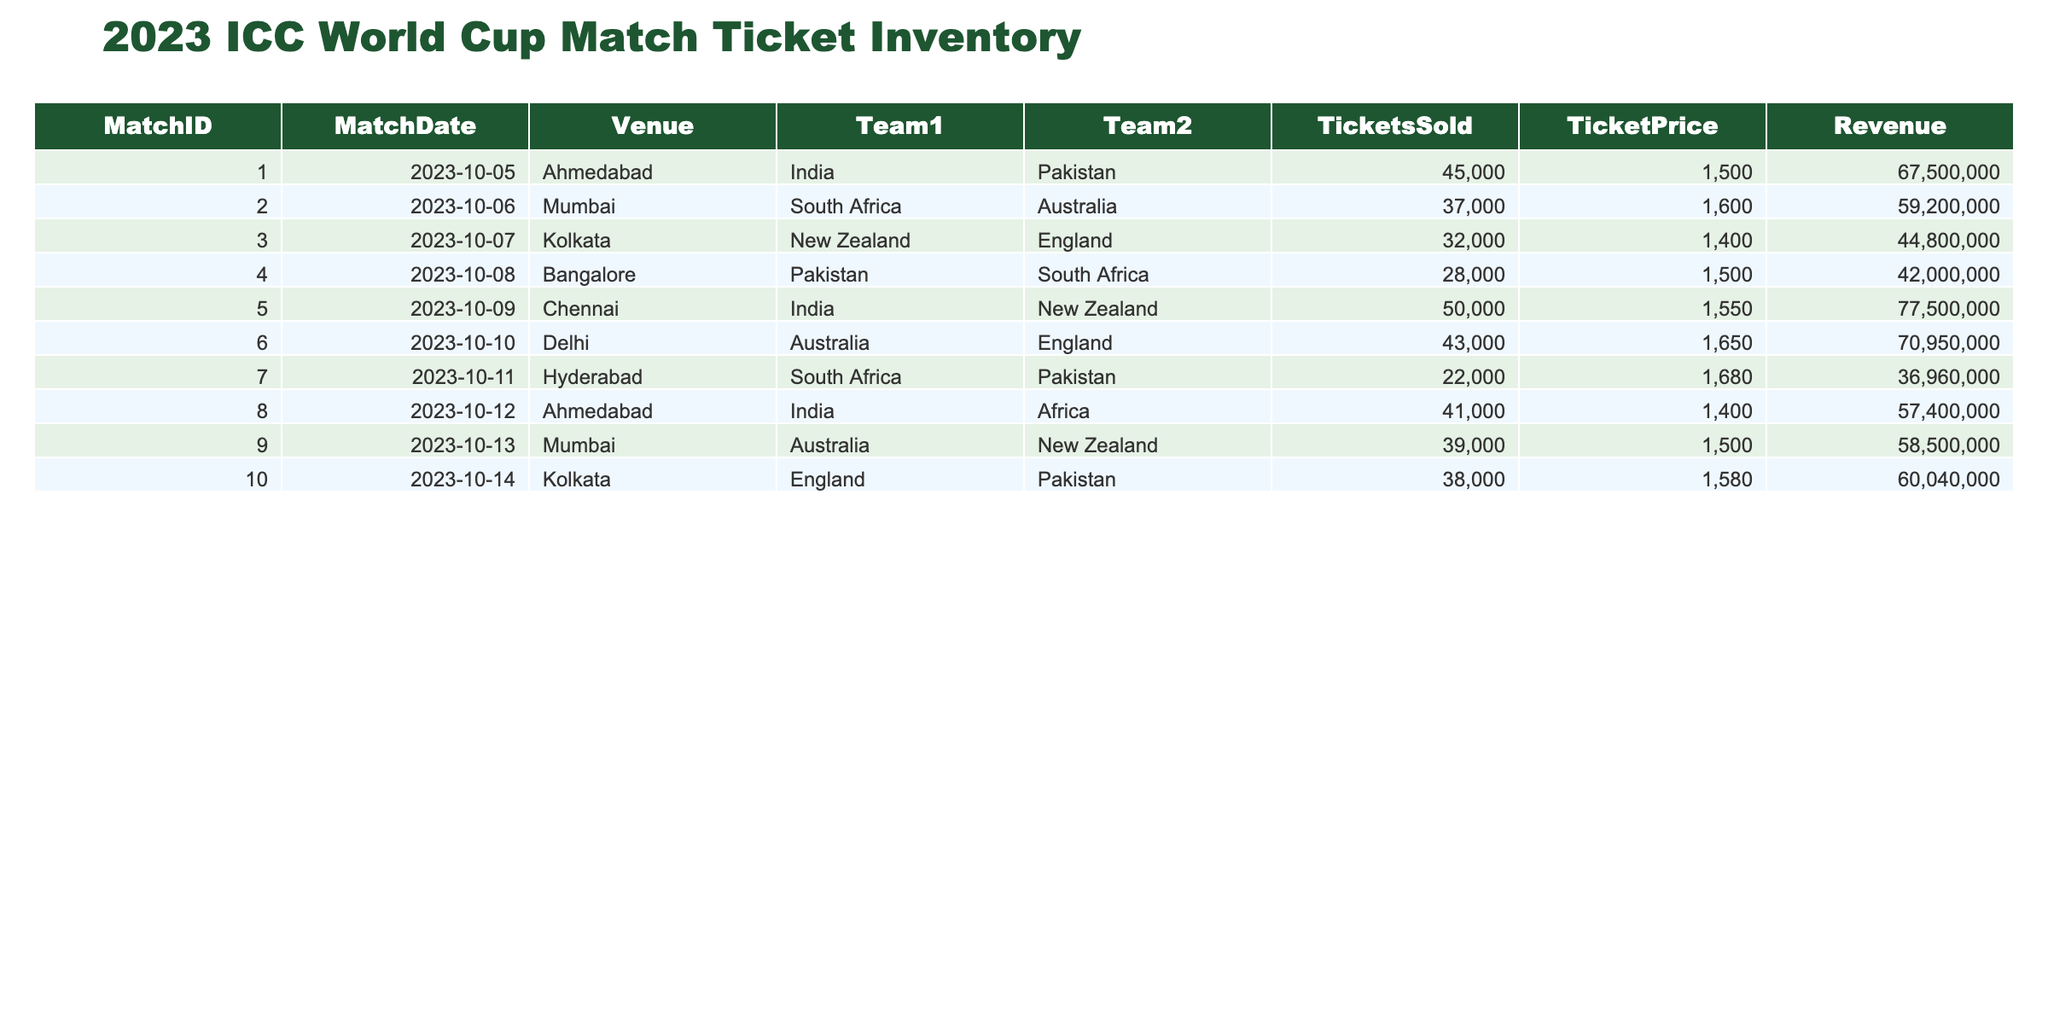What was the ticket price for the match between South Africa and Australia? By looking at the row for the match with MatchID 2, which features South Africa against Australia on October 6, 2023, we can see that the ticket price is listed as 1600.
Answer: 1600 How many tickets were sold for the match between India and Pakistan? The match involving India and Pakistan is recorded under MatchID 1. According to the table, it shows that 45000 tickets were sold for that match.
Answer: 45000 What is the total revenue generated from all the matches held at the venue in Ahmedabad? There are two matches at Ahmedabad (MatchID 1 and MatchID 8). The revenue for the first match is 67500000 and for the second is 57400000. Adding them together gives us 67500000 + 57400000 = 124900000.
Answer: 124900000 Did South Africa sell more tickets against Pakistan than against Australia? For the match against Pakistan (MatchID 4), they sold 28000 tickets, while against Australia (MatchID 2), they sold 37000 tickets. Since 37000 is greater than 28000, the statement is false.
Answer: No What is the average ticket price across all matches? The ticket prices are 1500, 1600, 1400, 1500, 1550, 1650, 1680, 1400, 1500, and 1580 for each match. First, we sum these prices: 1500 + 1600 + 1400 + 1500 + 1550 + 1650 + 1680 + 1400 + 1500 + 1580 = 15510. Then we divide by the number of matches (10): 15510 / 10 = 1551.
Answer: 1551 Which match generated the highest revenue and what amount was it? The revenues for the matches are as follows: MatchID 1 = 67500000, MatchID 2 = 59200000, MatchID 3 = 44800000, MatchID 4 = 42000000, MatchID 5 = 77500000, MatchID 6 = 70950000, MatchID 7 = 36960000, MatchID 8 = 57400000, MatchID 9 = 58500000, MatchID 10 = 60040000. The highest revenue is 77500000 from MatchID 5.
Answer: MatchID 5, 77500000 